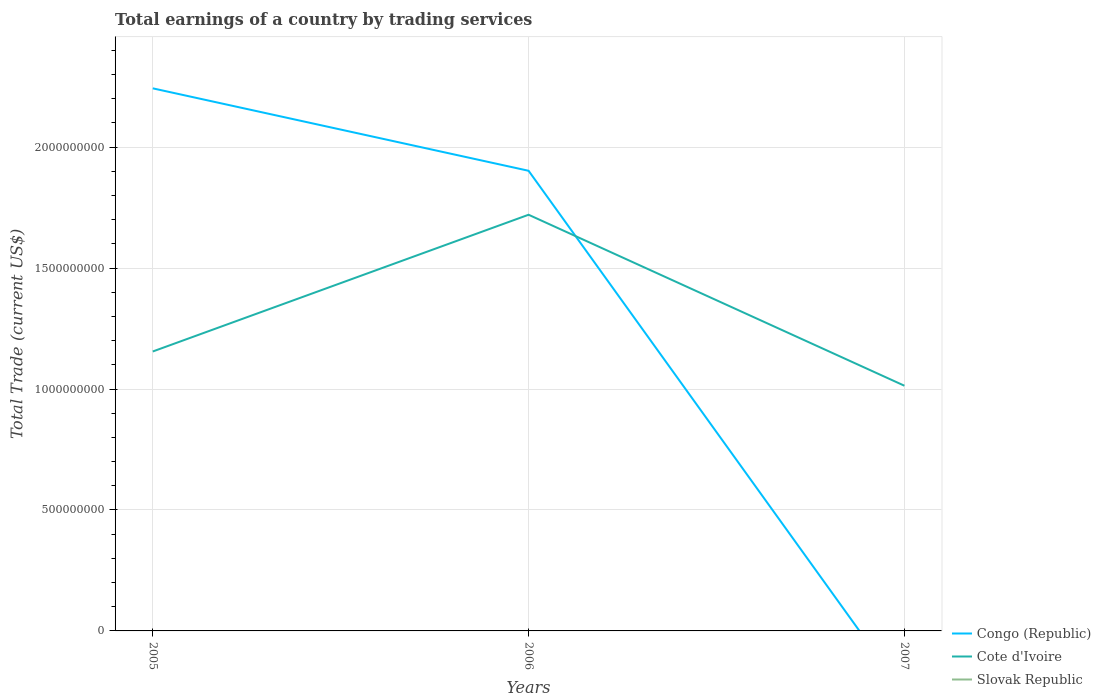How many different coloured lines are there?
Ensure brevity in your answer.  2. Does the line corresponding to Cote d'Ivoire intersect with the line corresponding to Congo (Republic)?
Provide a succinct answer. Yes. Across all years, what is the maximum total earnings in Congo (Republic)?
Offer a very short reply. 0. What is the total total earnings in Congo (Republic) in the graph?
Ensure brevity in your answer.  3.41e+08. What is the difference between the highest and the second highest total earnings in Cote d'Ivoire?
Keep it short and to the point. 7.07e+08. What is the difference between the highest and the lowest total earnings in Cote d'Ivoire?
Provide a short and direct response. 1. Is the total earnings in Cote d'Ivoire strictly greater than the total earnings in Slovak Republic over the years?
Provide a short and direct response. No. How many lines are there?
Offer a terse response. 2. How many years are there in the graph?
Your answer should be very brief. 3. Where does the legend appear in the graph?
Offer a terse response. Bottom right. How many legend labels are there?
Keep it short and to the point. 3. How are the legend labels stacked?
Offer a terse response. Vertical. What is the title of the graph?
Your answer should be very brief. Total earnings of a country by trading services. What is the label or title of the X-axis?
Your answer should be very brief. Years. What is the label or title of the Y-axis?
Ensure brevity in your answer.  Total Trade (current US$). What is the Total Trade (current US$) in Congo (Republic) in 2005?
Give a very brief answer. 2.24e+09. What is the Total Trade (current US$) in Cote d'Ivoire in 2005?
Ensure brevity in your answer.  1.16e+09. What is the Total Trade (current US$) of Congo (Republic) in 2006?
Give a very brief answer. 1.90e+09. What is the Total Trade (current US$) in Cote d'Ivoire in 2006?
Give a very brief answer. 1.72e+09. What is the Total Trade (current US$) in Slovak Republic in 2006?
Keep it short and to the point. 0. What is the Total Trade (current US$) of Cote d'Ivoire in 2007?
Keep it short and to the point. 1.01e+09. What is the Total Trade (current US$) in Slovak Republic in 2007?
Offer a terse response. 0. Across all years, what is the maximum Total Trade (current US$) in Congo (Republic)?
Offer a terse response. 2.24e+09. Across all years, what is the maximum Total Trade (current US$) in Cote d'Ivoire?
Keep it short and to the point. 1.72e+09. Across all years, what is the minimum Total Trade (current US$) of Cote d'Ivoire?
Give a very brief answer. 1.01e+09. What is the total Total Trade (current US$) of Congo (Republic) in the graph?
Provide a short and direct response. 4.15e+09. What is the total Total Trade (current US$) of Cote d'Ivoire in the graph?
Give a very brief answer. 3.89e+09. What is the difference between the Total Trade (current US$) in Congo (Republic) in 2005 and that in 2006?
Your response must be concise. 3.41e+08. What is the difference between the Total Trade (current US$) of Cote d'Ivoire in 2005 and that in 2006?
Give a very brief answer. -5.65e+08. What is the difference between the Total Trade (current US$) in Cote d'Ivoire in 2005 and that in 2007?
Give a very brief answer. 1.42e+08. What is the difference between the Total Trade (current US$) in Cote d'Ivoire in 2006 and that in 2007?
Keep it short and to the point. 7.07e+08. What is the difference between the Total Trade (current US$) of Congo (Republic) in 2005 and the Total Trade (current US$) of Cote d'Ivoire in 2006?
Your answer should be compact. 5.23e+08. What is the difference between the Total Trade (current US$) of Congo (Republic) in 2005 and the Total Trade (current US$) of Cote d'Ivoire in 2007?
Make the answer very short. 1.23e+09. What is the difference between the Total Trade (current US$) of Congo (Republic) in 2006 and the Total Trade (current US$) of Cote d'Ivoire in 2007?
Make the answer very short. 8.89e+08. What is the average Total Trade (current US$) in Congo (Republic) per year?
Provide a succinct answer. 1.38e+09. What is the average Total Trade (current US$) of Cote d'Ivoire per year?
Provide a short and direct response. 1.30e+09. What is the average Total Trade (current US$) of Slovak Republic per year?
Provide a short and direct response. 0. In the year 2005, what is the difference between the Total Trade (current US$) in Congo (Republic) and Total Trade (current US$) in Cote d'Ivoire?
Your answer should be compact. 1.09e+09. In the year 2006, what is the difference between the Total Trade (current US$) of Congo (Republic) and Total Trade (current US$) of Cote d'Ivoire?
Offer a terse response. 1.82e+08. What is the ratio of the Total Trade (current US$) in Congo (Republic) in 2005 to that in 2006?
Keep it short and to the point. 1.18. What is the ratio of the Total Trade (current US$) in Cote d'Ivoire in 2005 to that in 2006?
Ensure brevity in your answer.  0.67. What is the ratio of the Total Trade (current US$) in Cote d'Ivoire in 2005 to that in 2007?
Your response must be concise. 1.14. What is the ratio of the Total Trade (current US$) in Cote d'Ivoire in 2006 to that in 2007?
Offer a terse response. 1.7. What is the difference between the highest and the second highest Total Trade (current US$) in Cote d'Ivoire?
Your answer should be very brief. 5.65e+08. What is the difference between the highest and the lowest Total Trade (current US$) in Congo (Republic)?
Offer a terse response. 2.24e+09. What is the difference between the highest and the lowest Total Trade (current US$) in Cote d'Ivoire?
Provide a short and direct response. 7.07e+08. 